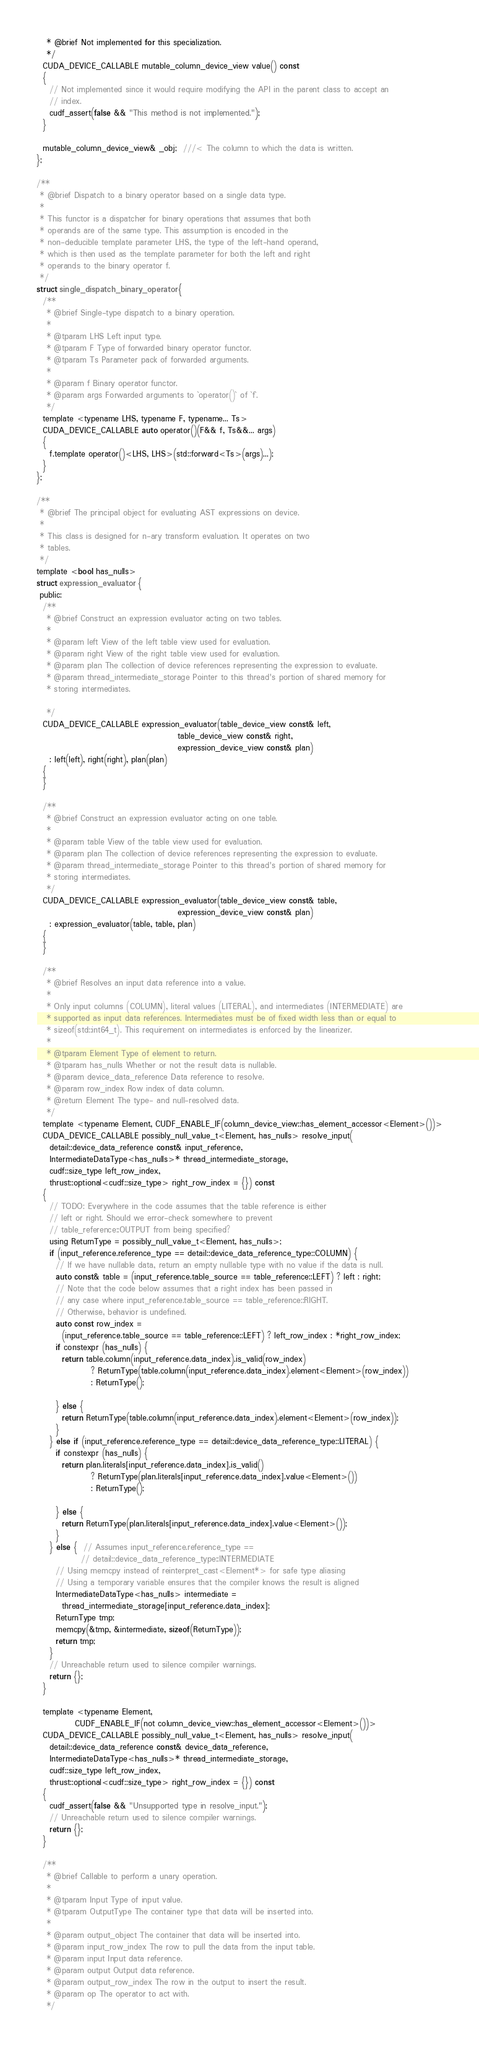<code> <loc_0><loc_0><loc_500><loc_500><_Cuda_>   * @brief Not implemented for this specialization.
   */
  CUDA_DEVICE_CALLABLE mutable_column_device_view value() const
  {
    // Not implemented since it would require modifying the API in the parent class to accept an
    // index.
    cudf_assert(false && "This method is not implemented.");
  }

  mutable_column_device_view& _obj;  ///< The column to which the data is written.
};

/**
 * @brief Dispatch to a binary operator based on a single data type.
 *
 * This functor is a dispatcher for binary operations that assumes that both
 * operands are of the same type. This assumption is encoded in the
 * non-deducible template parameter LHS, the type of the left-hand operand,
 * which is then used as the template parameter for both the left and right
 * operands to the binary operator f.
 */
struct single_dispatch_binary_operator {
  /**
   * @brief Single-type dispatch to a binary operation.
   *
   * @tparam LHS Left input type.
   * @tparam F Type of forwarded binary operator functor.
   * @tparam Ts Parameter pack of forwarded arguments.
   *
   * @param f Binary operator functor.
   * @param args Forwarded arguments to `operator()` of `f`.
   */
  template <typename LHS, typename F, typename... Ts>
  CUDA_DEVICE_CALLABLE auto operator()(F&& f, Ts&&... args)
  {
    f.template operator()<LHS, LHS>(std::forward<Ts>(args)...);
  }
};

/**
 * @brief The principal object for evaluating AST expressions on device.
 *
 * This class is designed for n-ary transform evaluation. It operates on two
 * tables.
 */
template <bool has_nulls>
struct expression_evaluator {
 public:
  /**
   * @brief Construct an expression evaluator acting on two tables.
   *
   * @param left View of the left table view used for evaluation.
   * @param right View of the right table view used for evaluation.
   * @param plan The collection of device references representing the expression to evaluate.
   * @param thread_intermediate_storage Pointer to this thread's portion of shared memory for
   * storing intermediates.

   */
  CUDA_DEVICE_CALLABLE expression_evaluator(table_device_view const& left,
                                            table_device_view const& right,
                                            expression_device_view const& plan)
    : left(left), right(right), plan(plan)
  {
  }

  /**
   * @brief Construct an expression evaluator acting on one table.
   *
   * @param table View of the table view used for evaluation.
   * @param plan The collection of device references representing the expression to evaluate.
   * @param thread_intermediate_storage Pointer to this thread's portion of shared memory for
   * storing intermediates.
   */
  CUDA_DEVICE_CALLABLE expression_evaluator(table_device_view const& table,
                                            expression_device_view const& plan)
    : expression_evaluator(table, table, plan)
  {
  }

  /**
   * @brief Resolves an input data reference into a value.
   *
   * Only input columns (COLUMN), literal values (LITERAL), and intermediates (INTERMEDIATE) are
   * supported as input data references. Intermediates must be of fixed width less than or equal to
   * sizeof(std::int64_t). This requirement on intermediates is enforced by the linearizer.
   *
   * @tparam Element Type of element to return.
   * @tparam has_nulls Whether or not the result data is nullable.
   * @param device_data_reference Data reference to resolve.
   * @param row_index Row index of data column.
   * @return Element The type- and null-resolved data.
   */
  template <typename Element, CUDF_ENABLE_IF(column_device_view::has_element_accessor<Element>())>
  CUDA_DEVICE_CALLABLE possibly_null_value_t<Element, has_nulls> resolve_input(
    detail::device_data_reference const& input_reference,
    IntermediateDataType<has_nulls>* thread_intermediate_storage,
    cudf::size_type left_row_index,
    thrust::optional<cudf::size_type> right_row_index = {}) const
  {
    // TODO: Everywhere in the code assumes that the table reference is either
    // left or right. Should we error-check somewhere to prevent
    // table_reference::OUTPUT from being specified?
    using ReturnType = possibly_null_value_t<Element, has_nulls>;
    if (input_reference.reference_type == detail::device_data_reference_type::COLUMN) {
      // If we have nullable data, return an empty nullable type with no value if the data is null.
      auto const& table = (input_reference.table_source == table_reference::LEFT) ? left : right;
      // Note that the code below assumes that a right index has been passed in
      // any case where input_reference.table_source == table_reference::RIGHT.
      // Otherwise, behavior is undefined.
      auto const row_index =
        (input_reference.table_source == table_reference::LEFT) ? left_row_index : *right_row_index;
      if constexpr (has_nulls) {
        return table.column(input_reference.data_index).is_valid(row_index)
                 ? ReturnType(table.column(input_reference.data_index).element<Element>(row_index))
                 : ReturnType();

      } else {
        return ReturnType(table.column(input_reference.data_index).element<Element>(row_index));
      }
    } else if (input_reference.reference_type == detail::device_data_reference_type::LITERAL) {
      if constexpr (has_nulls) {
        return plan.literals[input_reference.data_index].is_valid()
                 ? ReturnType(plan.literals[input_reference.data_index].value<Element>())
                 : ReturnType();

      } else {
        return ReturnType(plan.literals[input_reference.data_index].value<Element>());
      }
    } else {  // Assumes input_reference.reference_type ==
              // detail::device_data_reference_type::INTERMEDIATE
      // Using memcpy instead of reinterpret_cast<Element*> for safe type aliasing
      // Using a temporary variable ensures that the compiler knows the result is aligned
      IntermediateDataType<has_nulls> intermediate =
        thread_intermediate_storage[input_reference.data_index];
      ReturnType tmp;
      memcpy(&tmp, &intermediate, sizeof(ReturnType));
      return tmp;
    }
    // Unreachable return used to silence compiler warnings.
    return {};
  }

  template <typename Element,
            CUDF_ENABLE_IF(not column_device_view::has_element_accessor<Element>())>
  CUDA_DEVICE_CALLABLE possibly_null_value_t<Element, has_nulls> resolve_input(
    detail::device_data_reference const& device_data_reference,
    IntermediateDataType<has_nulls>* thread_intermediate_storage,
    cudf::size_type left_row_index,
    thrust::optional<cudf::size_type> right_row_index = {}) const
  {
    cudf_assert(false && "Unsupported type in resolve_input.");
    // Unreachable return used to silence compiler warnings.
    return {};
  }

  /**
   * @brief Callable to perform a unary operation.
   *
   * @tparam Input Type of input value.
   * @tparam OutputType The container type that data will be inserted into.
   *
   * @param output_object The container that data will be inserted into.
   * @param input_row_index The row to pull the data from the input table.
   * @param input Input data reference.
   * @param output Output data reference.
   * @param output_row_index The row in the output to insert the result.
   * @param op The operator to act with.
   */</code> 